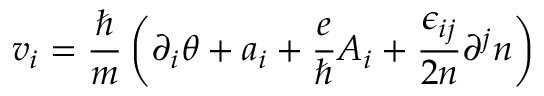<formula> <loc_0><loc_0><loc_500><loc_500>v _ { i } = \frac { } { m } \left ( \partial _ { i } \theta + a _ { i } + \frac { e } { } A _ { i } + \frac { \epsilon _ { i j } } { 2 n } \partial ^ { j } n \right )</formula> 